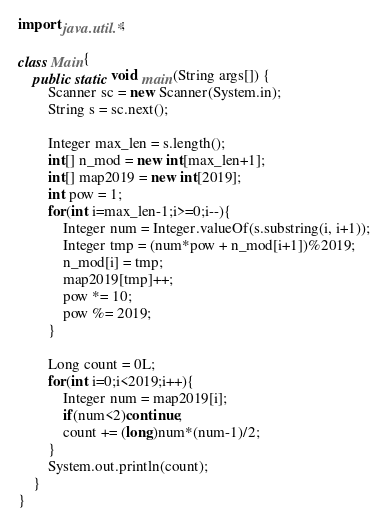<code> <loc_0><loc_0><loc_500><loc_500><_Java_>import java.util.*;

class Main{
    public static void main(String args[]) {
        Scanner sc = new Scanner(System.in);
        String s = sc.next();

        Integer max_len = s.length();
        int[] n_mod = new int[max_len+1];
        int[] map2019 = new int[2019];
        int pow = 1;
        for(int i=max_len-1;i>=0;i--){
            Integer num = Integer.valueOf(s.substring(i, i+1));
            Integer tmp = (num*pow + n_mod[i+1])%2019;
            n_mod[i] = tmp;
            map2019[tmp]++;
            pow *= 10;
            pow %= 2019;
        }

        Long count = 0L;
        for(int i=0;i<2019;i++){
            Integer num = map2019[i];
            if(num<2)continue;
            count += (long)num*(num-1)/2;
        }
        System.out.println(count);
    }
}
</code> 